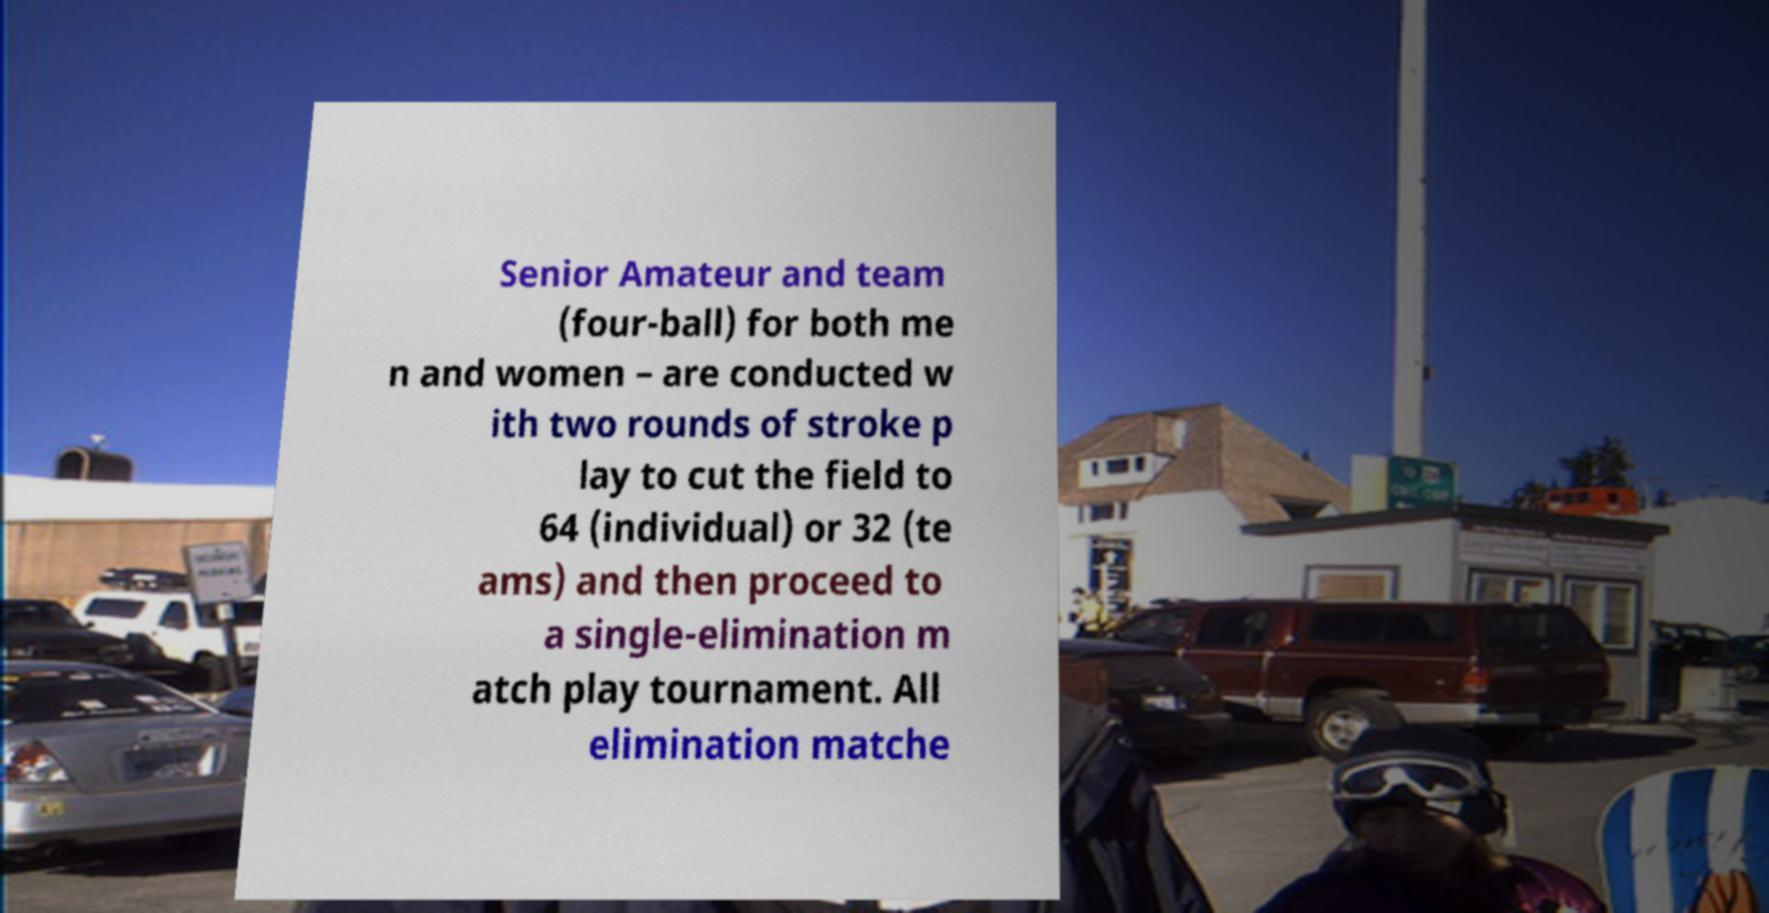For documentation purposes, I need the text within this image transcribed. Could you provide that? Senior Amateur and team (four-ball) for both me n and women – are conducted w ith two rounds of stroke p lay to cut the field to 64 (individual) or 32 (te ams) and then proceed to a single-elimination m atch play tournament. All elimination matche 